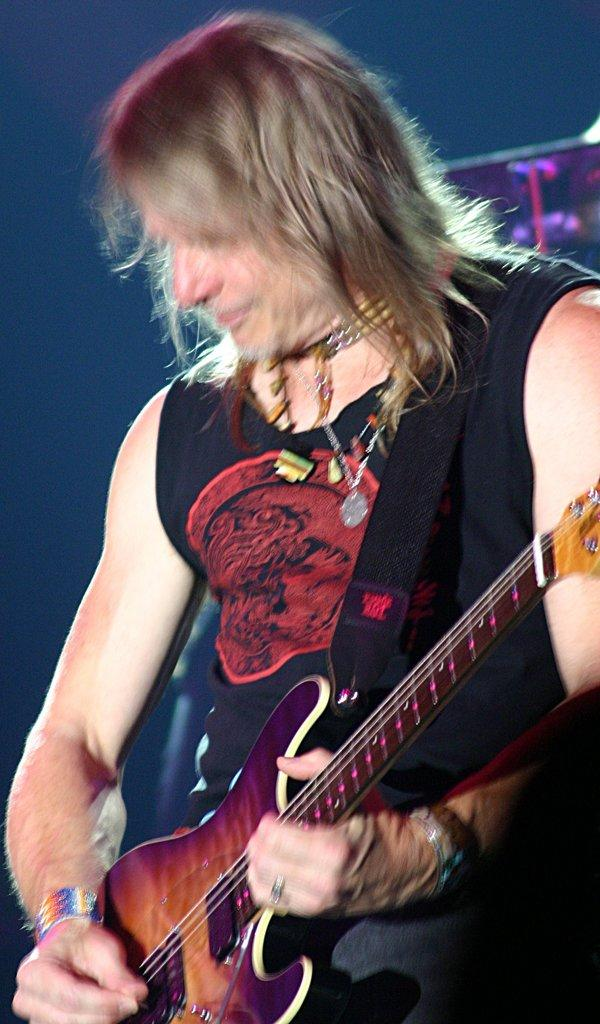What is the main subject of the image? The main subject of the image is a man. What is the man doing in the image? The man is standing in the image. What object is the man holding in the image? The man is holding a guitar in the image. What type of brick is the man using to play the guitar in the image? There is no brick present in the image, and the man is not using any brick to play the guitar. 